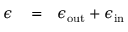Convert formula to latex. <formula><loc_0><loc_0><loc_500><loc_500>\begin{array} { r l r } { \epsilon } & = } & { \epsilon _ { o u t } + \epsilon _ { i n } } \end{array}</formula> 